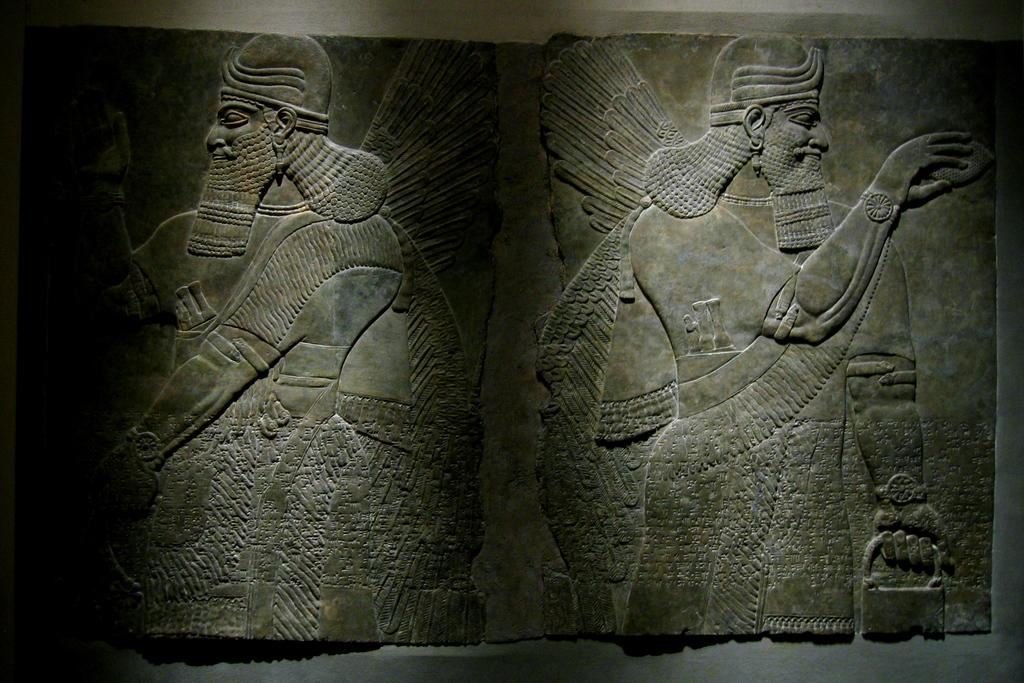What is the main subject of the image? The main subject of the image is a carved stone. Can you describe the setting of the image? In the background of the image, there is a wall. Where is the library located in the image? There is no library present in the image; it features a carved stone and a wall in the background. Can you tell me what type of lunch dad is eating in the image? There is no dad or lunch present in the image; it only shows a carved stone and a wall in the background. 